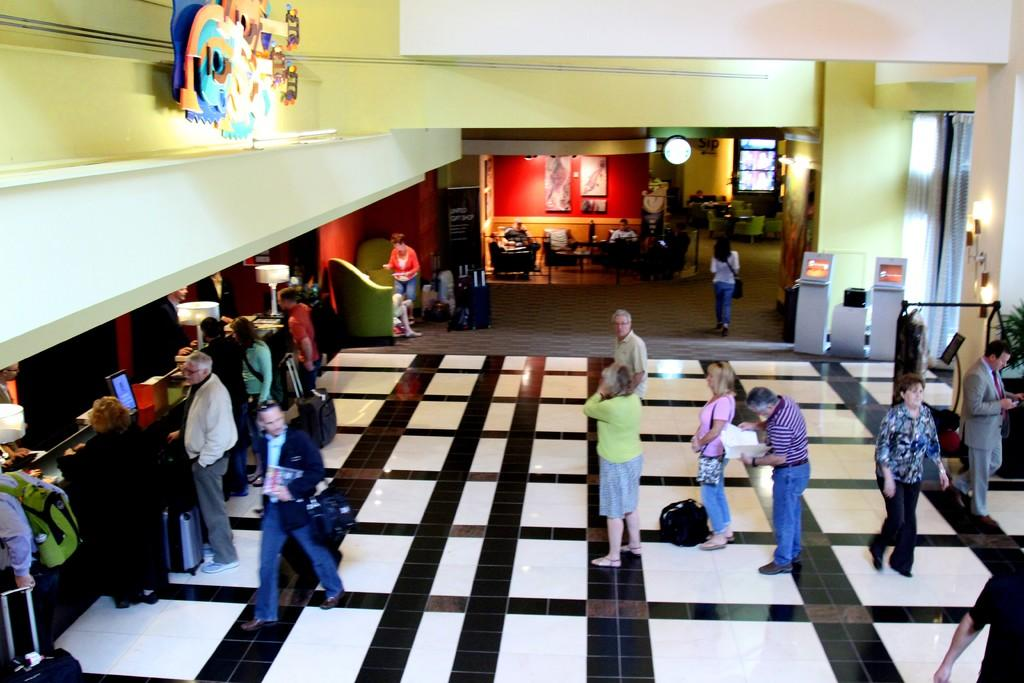What can be seen in the background of the image? There is a wall in the image. Who or what is present in the image? There are people in the image. How would you describe the floor in the image? The floor has white and black color tiles. Are there any decorative items visible in the image? Yes, there are photo frames in the image. What type of lighting is present in the image? There are lamps in the image. What electronic devices can be seen in the image? There are laptops in the image. What type of milk is being served in the lunchroom in the image? There is no lunchroom or milk present in the image. What material is the metal sculpture made of in the image? There is no metal sculpture present in the image. 